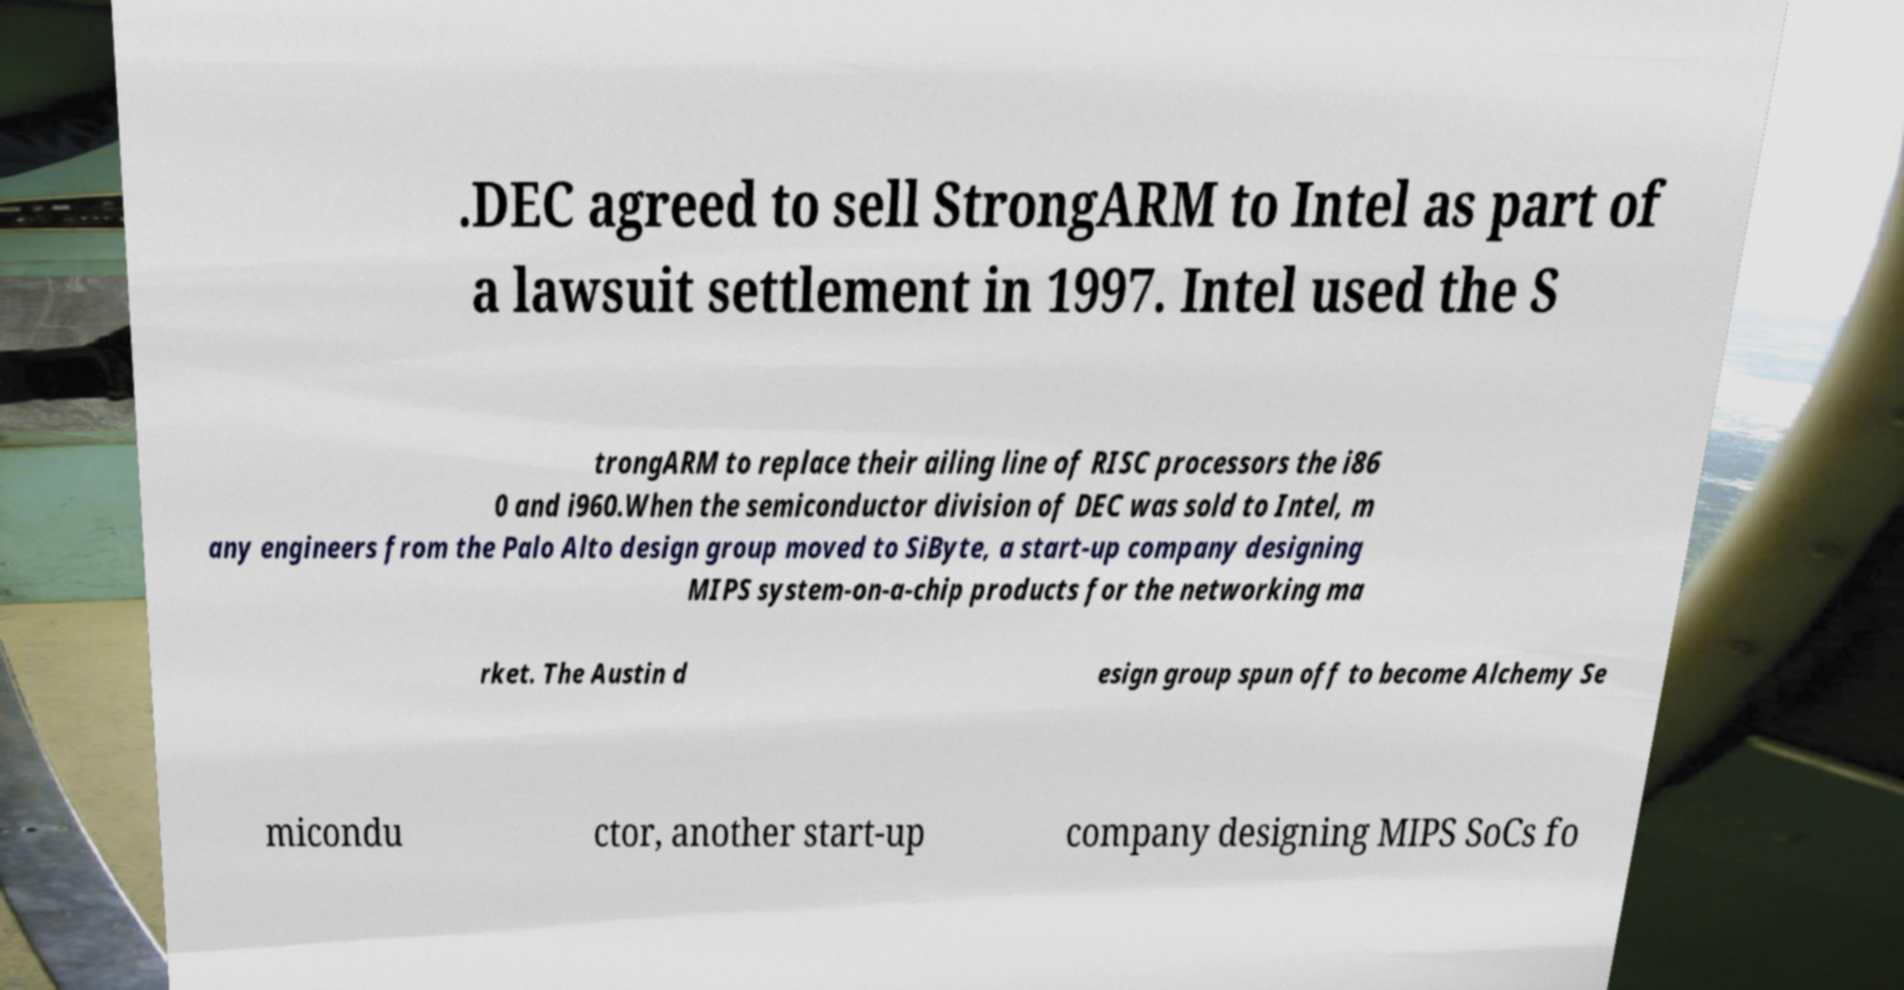Could you extract and type out the text from this image? .DEC agreed to sell StrongARM to Intel as part of a lawsuit settlement in 1997. Intel used the S trongARM to replace their ailing line of RISC processors the i86 0 and i960.When the semiconductor division of DEC was sold to Intel, m any engineers from the Palo Alto design group moved to SiByte, a start-up company designing MIPS system-on-a-chip products for the networking ma rket. The Austin d esign group spun off to become Alchemy Se micondu ctor, another start-up company designing MIPS SoCs fo 